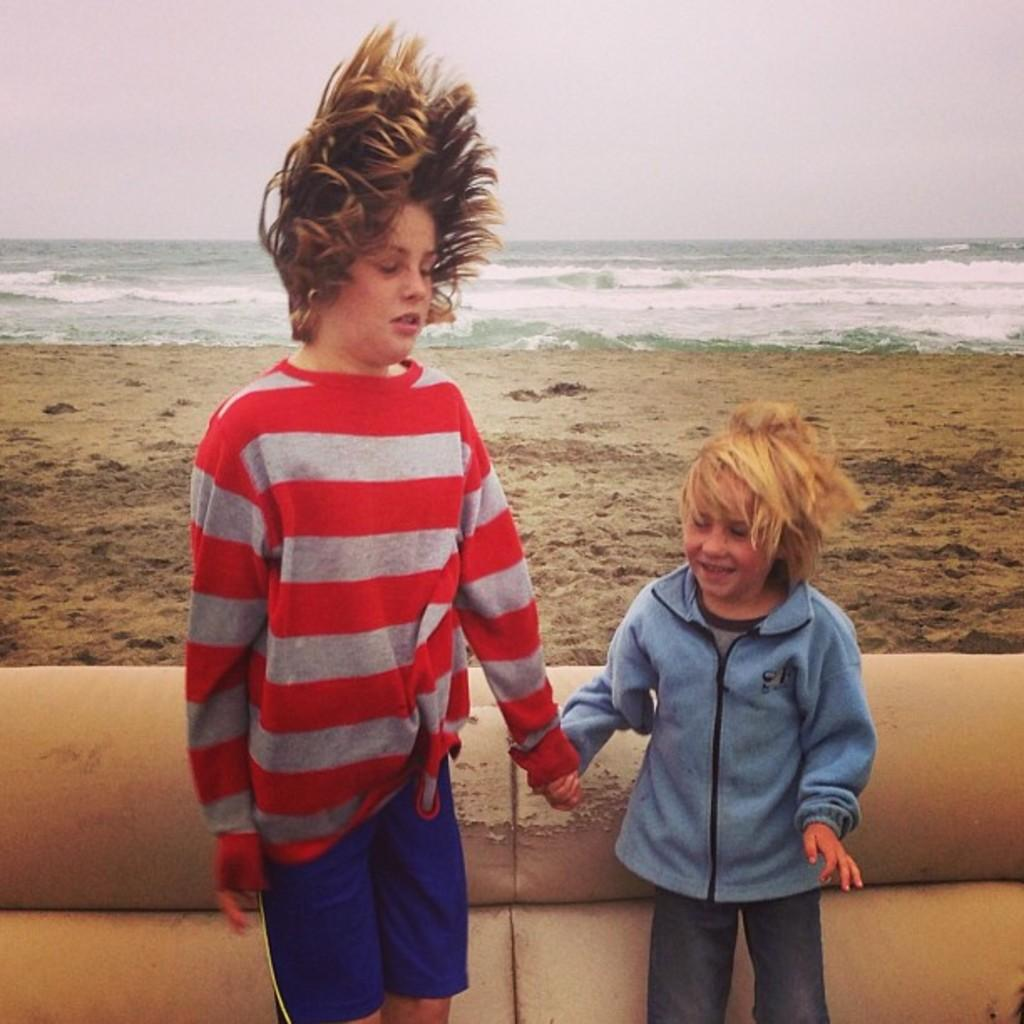How many people are in the image? There are two persons standing in the image. What are the persons doing in the image? The persons are standing at pipes. What can be seen in the background of the image? There is sand, water, and the sky visible in the background of the image. What type of rod is the stranger using to judge the competition in the image? There is no stranger, rod, or competition present in the image. 